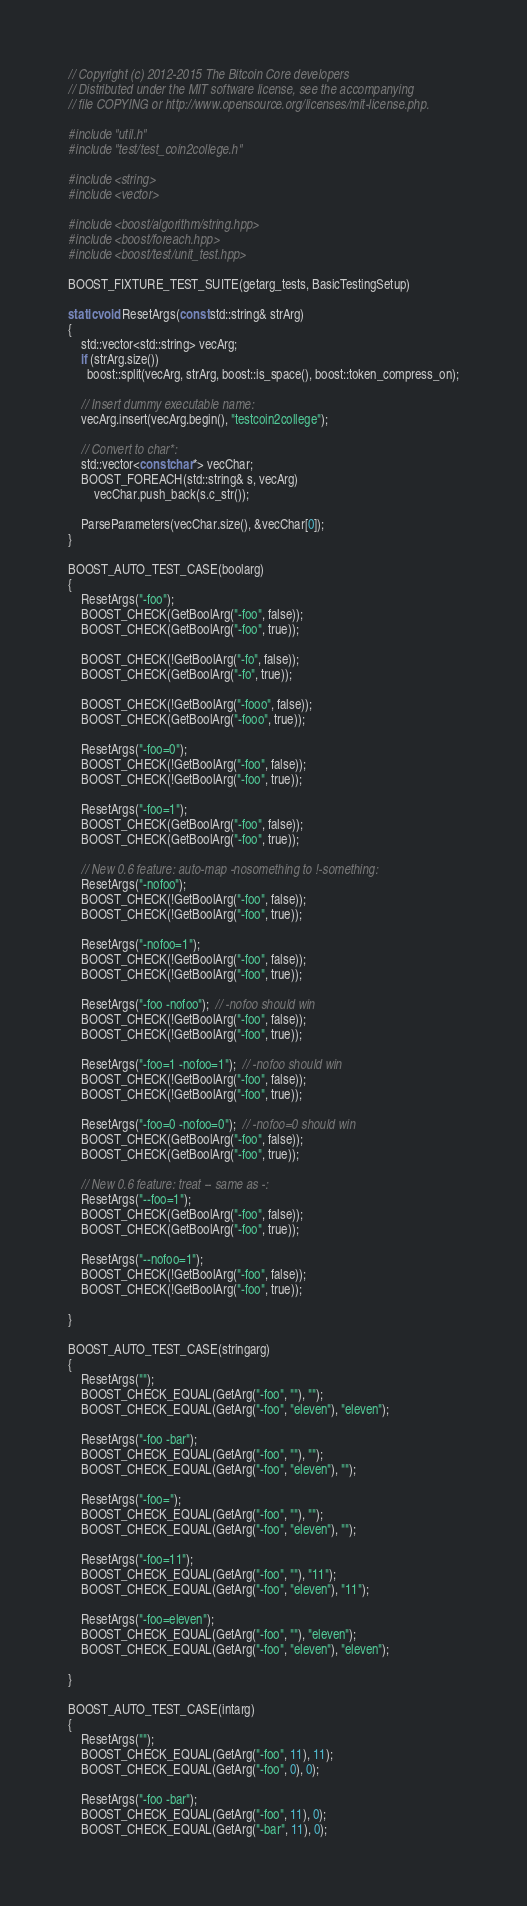<code> <loc_0><loc_0><loc_500><loc_500><_C++_>// Copyright (c) 2012-2015 The Bitcoin Core developers
// Distributed under the MIT software license, see the accompanying
// file COPYING or http://www.opensource.org/licenses/mit-license.php.

#include "util.h"
#include "test/test_coin2college.h"

#include <string>
#include <vector>

#include <boost/algorithm/string.hpp>
#include <boost/foreach.hpp>
#include <boost/test/unit_test.hpp>

BOOST_FIXTURE_TEST_SUITE(getarg_tests, BasicTestingSetup)

static void ResetArgs(const std::string& strArg)
{
    std::vector<std::string> vecArg;
    if (strArg.size())
      boost::split(vecArg, strArg, boost::is_space(), boost::token_compress_on);

    // Insert dummy executable name:
    vecArg.insert(vecArg.begin(), "testcoin2college");

    // Convert to char*:
    std::vector<const char*> vecChar;
    BOOST_FOREACH(std::string& s, vecArg)
        vecChar.push_back(s.c_str());

    ParseParameters(vecChar.size(), &vecChar[0]);
}

BOOST_AUTO_TEST_CASE(boolarg)
{
    ResetArgs("-foo");
    BOOST_CHECK(GetBoolArg("-foo", false));
    BOOST_CHECK(GetBoolArg("-foo", true));

    BOOST_CHECK(!GetBoolArg("-fo", false));
    BOOST_CHECK(GetBoolArg("-fo", true));

    BOOST_CHECK(!GetBoolArg("-fooo", false));
    BOOST_CHECK(GetBoolArg("-fooo", true));

    ResetArgs("-foo=0");
    BOOST_CHECK(!GetBoolArg("-foo", false));
    BOOST_CHECK(!GetBoolArg("-foo", true));

    ResetArgs("-foo=1");
    BOOST_CHECK(GetBoolArg("-foo", false));
    BOOST_CHECK(GetBoolArg("-foo", true));

    // New 0.6 feature: auto-map -nosomething to !-something:
    ResetArgs("-nofoo");
    BOOST_CHECK(!GetBoolArg("-foo", false));
    BOOST_CHECK(!GetBoolArg("-foo", true));

    ResetArgs("-nofoo=1");
    BOOST_CHECK(!GetBoolArg("-foo", false));
    BOOST_CHECK(!GetBoolArg("-foo", true));

    ResetArgs("-foo -nofoo");  // -nofoo should win
    BOOST_CHECK(!GetBoolArg("-foo", false));
    BOOST_CHECK(!GetBoolArg("-foo", true));

    ResetArgs("-foo=1 -nofoo=1");  // -nofoo should win
    BOOST_CHECK(!GetBoolArg("-foo", false));
    BOOST_CHECK(!GetBoolArg("-foo", true));

    ResetArgs("-foo=0 -nofoo=0");  // -nofoo=0 should win
    BOOST_CHECK(GetBoolArg("-foo", false));
    BOOST_CHECK(GetBoolArg("-foo", true));

    // New 0.6 feature: treat -- same as -:
    ResetArgs("--foo=1");
    BOOST_CHECK(GetBoolArg("-foo", false));
    BOOST_CHECK(GetBoolArg("-foo", true));

    ResetArgs("--nofoo=1");
    BOOST_CHECK(!GetBoolArg("-foo", false));
    BOOST_CHECK(!GetBoolArg("-foo", true));

}

BOOST_AUTO_TEST_CASE(stringarg)
{
    ResetArgs("");
    BOOST_CHECK_EQUAL(GetArg("-foo", ""), "");
    BOOST_CHECK_EQUAL(GetArg("-foo", "eleven"), "eleven");

    ResetArgs("-foo -bar");
    BOOST_CHECK_EQUAL(GetArg("-foo", ""), "");
    BOOST_CHECK_EQUAL(GetArg("-foo", "eleven"), "");

    ResetArgs("-foo=");
    BOOST_CHECK_EQUAL(GetArg("-foo", ""), "");
    BOOST_CHECK_EQUAL(GetArg("-foo", "eleven"), "");

    ResetArgs("-foo=11");
    BOOST_CHECK_EQUAL(GetArg("-foo", ""), "11");
    BOOST_CHECK_EQUAL(GetArg("-foo", "eleven"), "11");

    ResetArgs("-foo=eleven");
    BOOST_CHECK_EQUAL(GetArg("-foo", ""), "eleven");
    BOOST_CHECK_EQUAL(GetArg("-foo", "eleven"), "eleven");

}

BOOST_AUTO_TEST_CASE(intarg)
{
    ResetArgs("");
    BOOST_CHECK_EQUAL(GetArg("-foo", 11), 11);
    BOOST_CHECK_EQUAL(GetArg("-foo", 0), 0);

    ResetArgs("-foo -bar");
    BOOST_CHECK_EQUAL(GetArg("-foo", 11), 0);
    BOOST_CHECK_EQUAL(GetArg("-bar", 11), 0);
</code> 